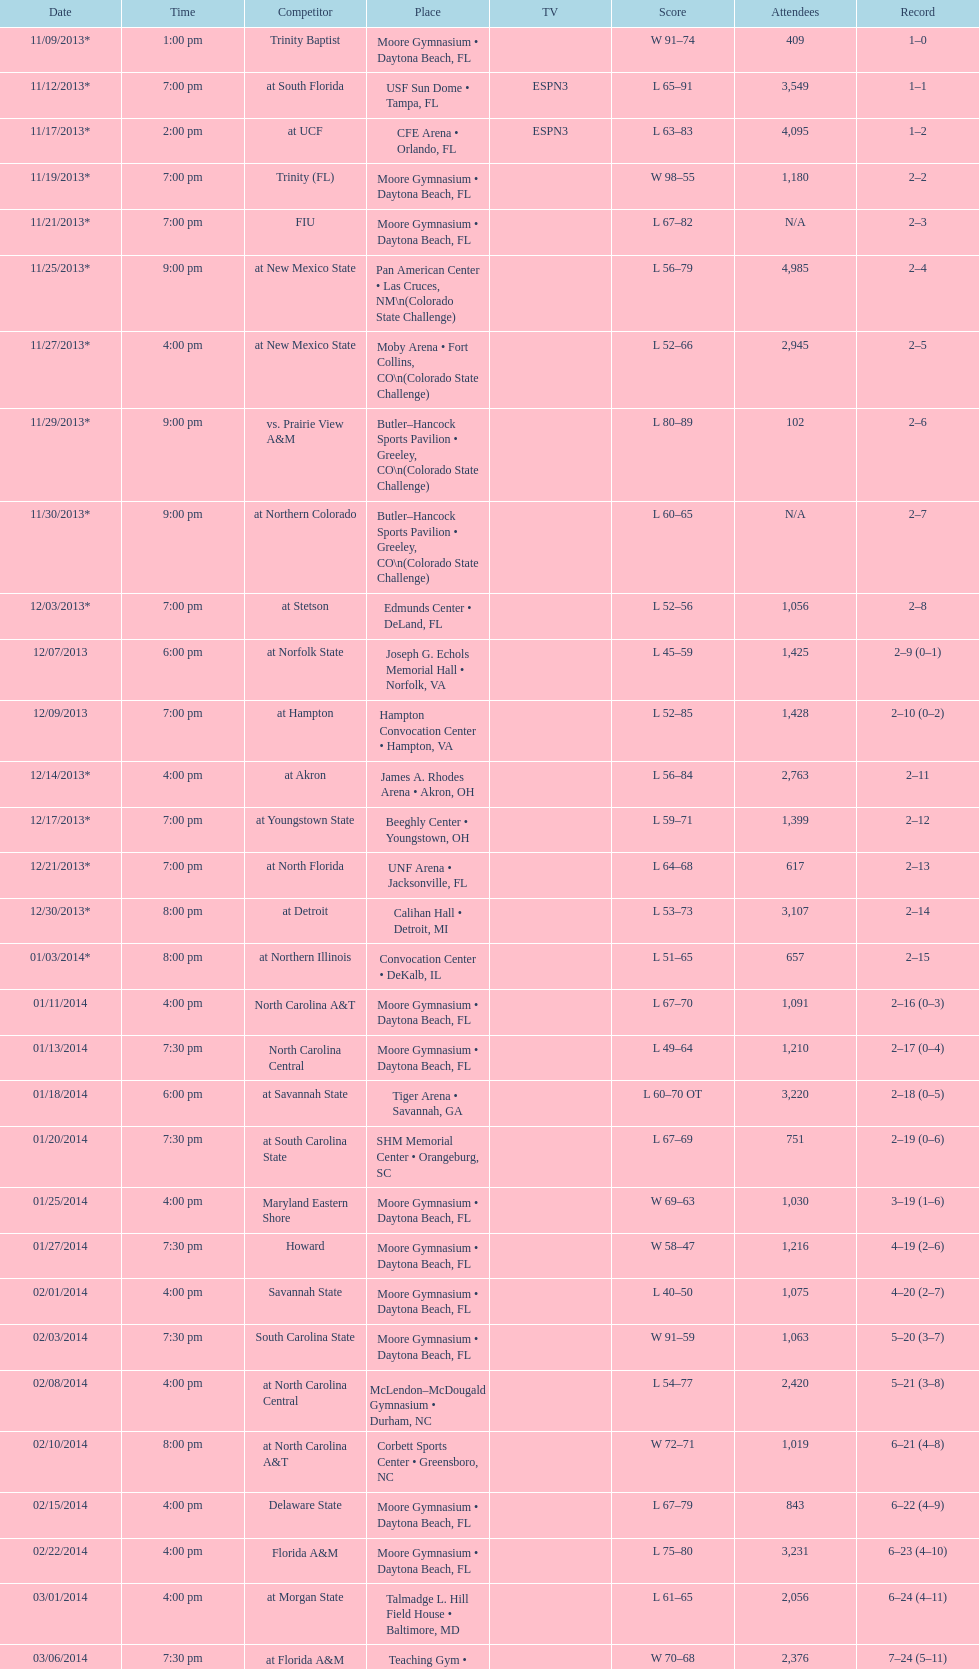How many games had more than 1,500 in attendance? 12. 